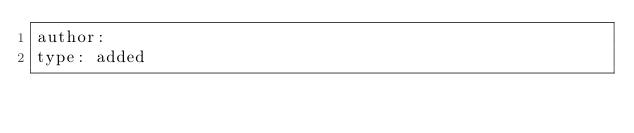<code> <loc_0><loc_0><loc_500><loc_500><_YAML_>author:
type: added
</code> 